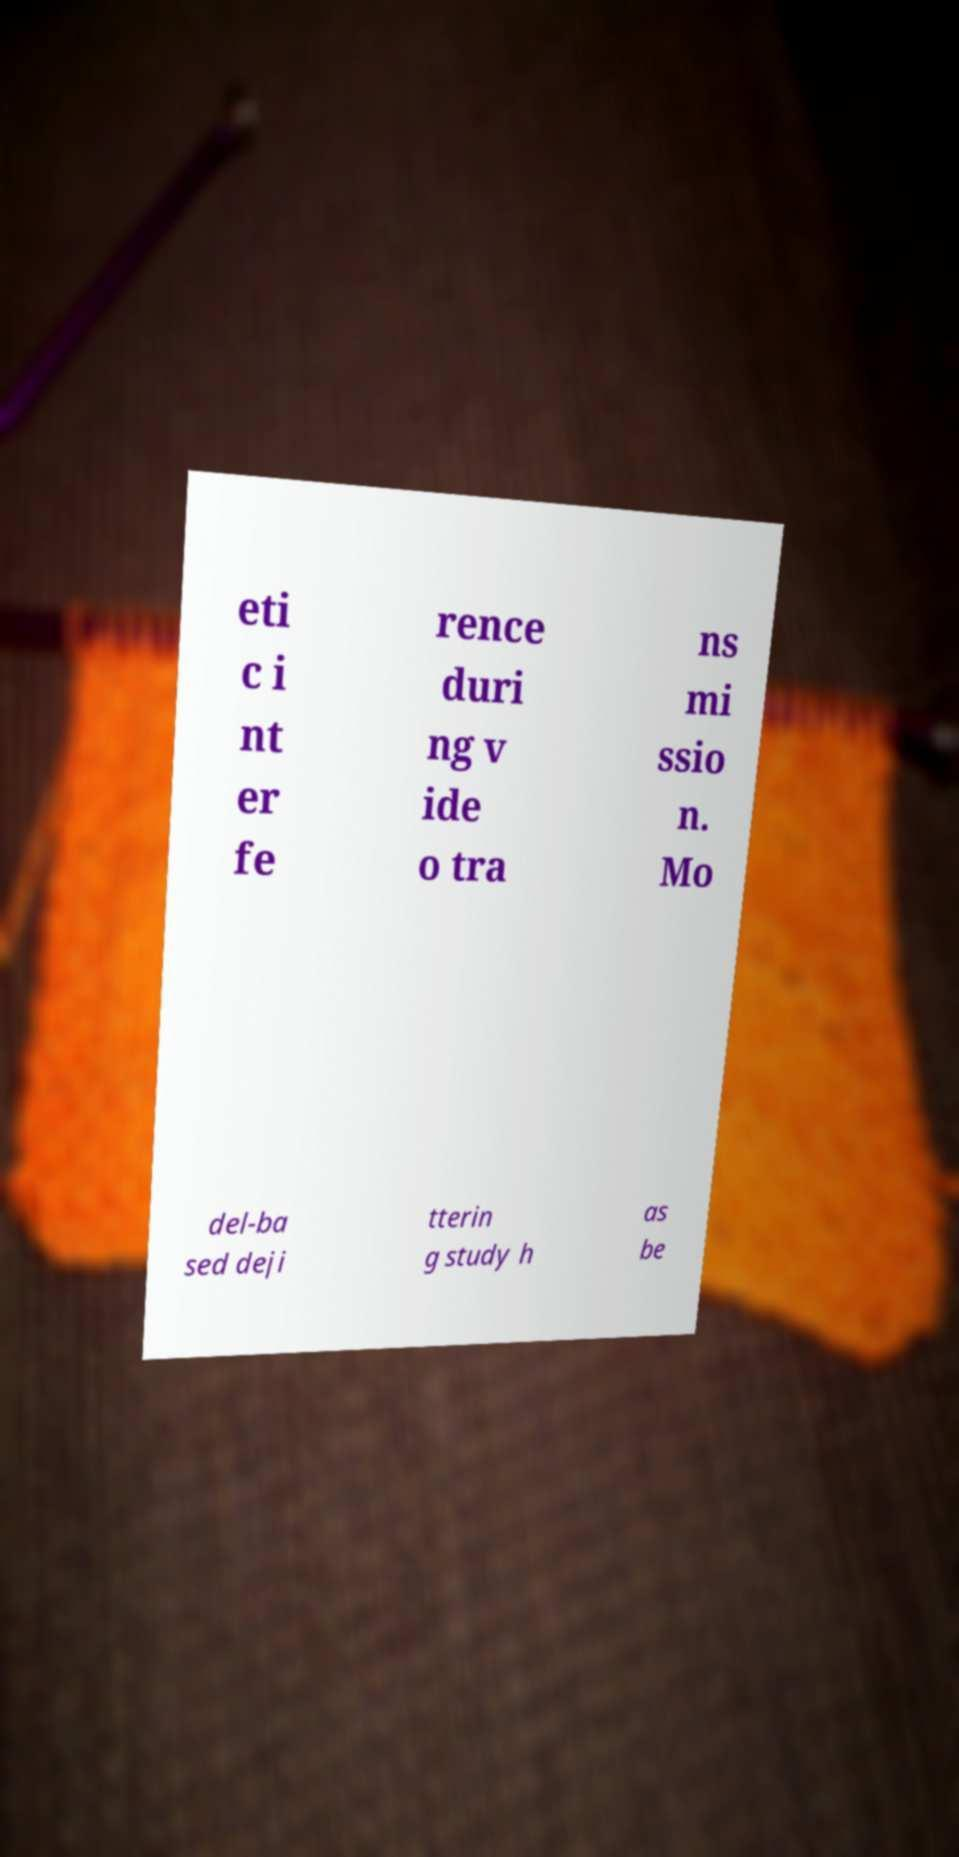For documentation purposes, I need the text within this image transcribed. Could you provide that? eti c i nt er fe rence duri ng v ide o tra ns mi ssio n. Mo del-ba sed deji tterin g study h as be 